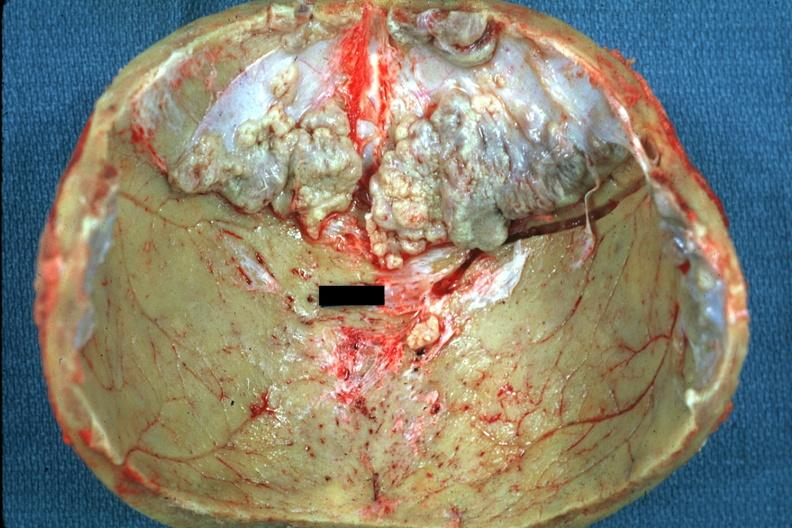what is present?
Answer the question using a single word or phrase. Exostosis 